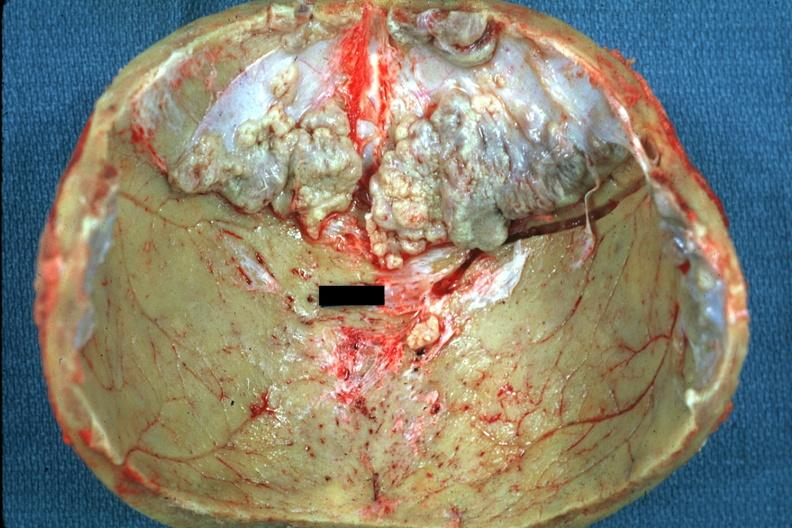what is present?
Answer the question using a single word or phrase. Exostosis 